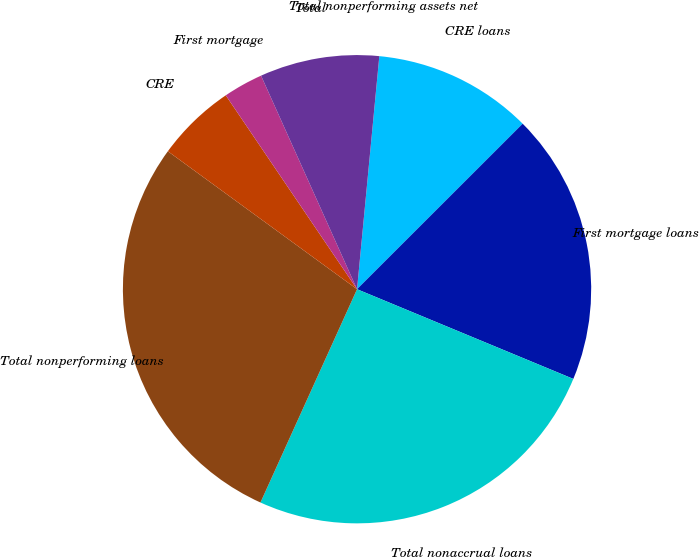Convert chart to OTSL. <chart><loc_0><loc_0><loc_500><loc_500><pie_chart><fcel>CRE loans<fcel>First mortgage loans<fcel>Total nonaccrual loans<fcel>Total nonperforming loans<fcel>CRE<fcel>First mortgage<fcel>Total<fcel>Total nonperforming assets net<nl><fcel>10.99%<fcel>18.75%<fcel>25.51%<fcel>28.26%<fcel>5.5%<fcel>2.75%<fcel>8.24%<fcel>0.0%<nl></chart> 